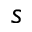Convert formula to latex. <formula><loc_0><loc_0><loc_500><loc_500>s</formula> 